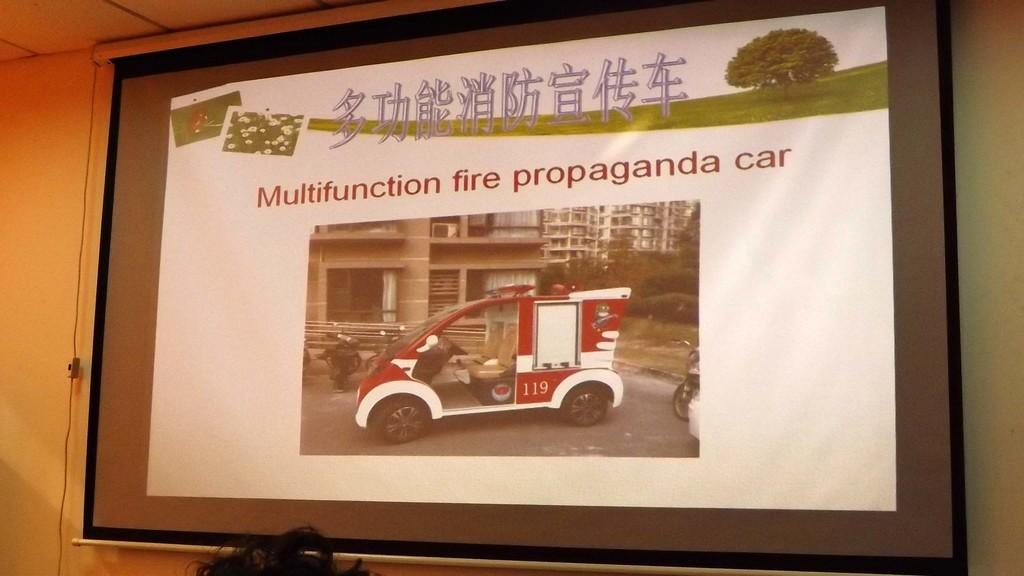What is the main object in the image? There is a screen in the image. What can be seen behind the screen? There is a wall in the image. What is located at the bottom of the image? Hair is visible at the bottom of the image. What type of tin can be seen on the wall in the image? There is no tin present in the image; only a screen and a wall are visible. Is the minister wearing a boot in the image? There is no minister or boot present in the image. 